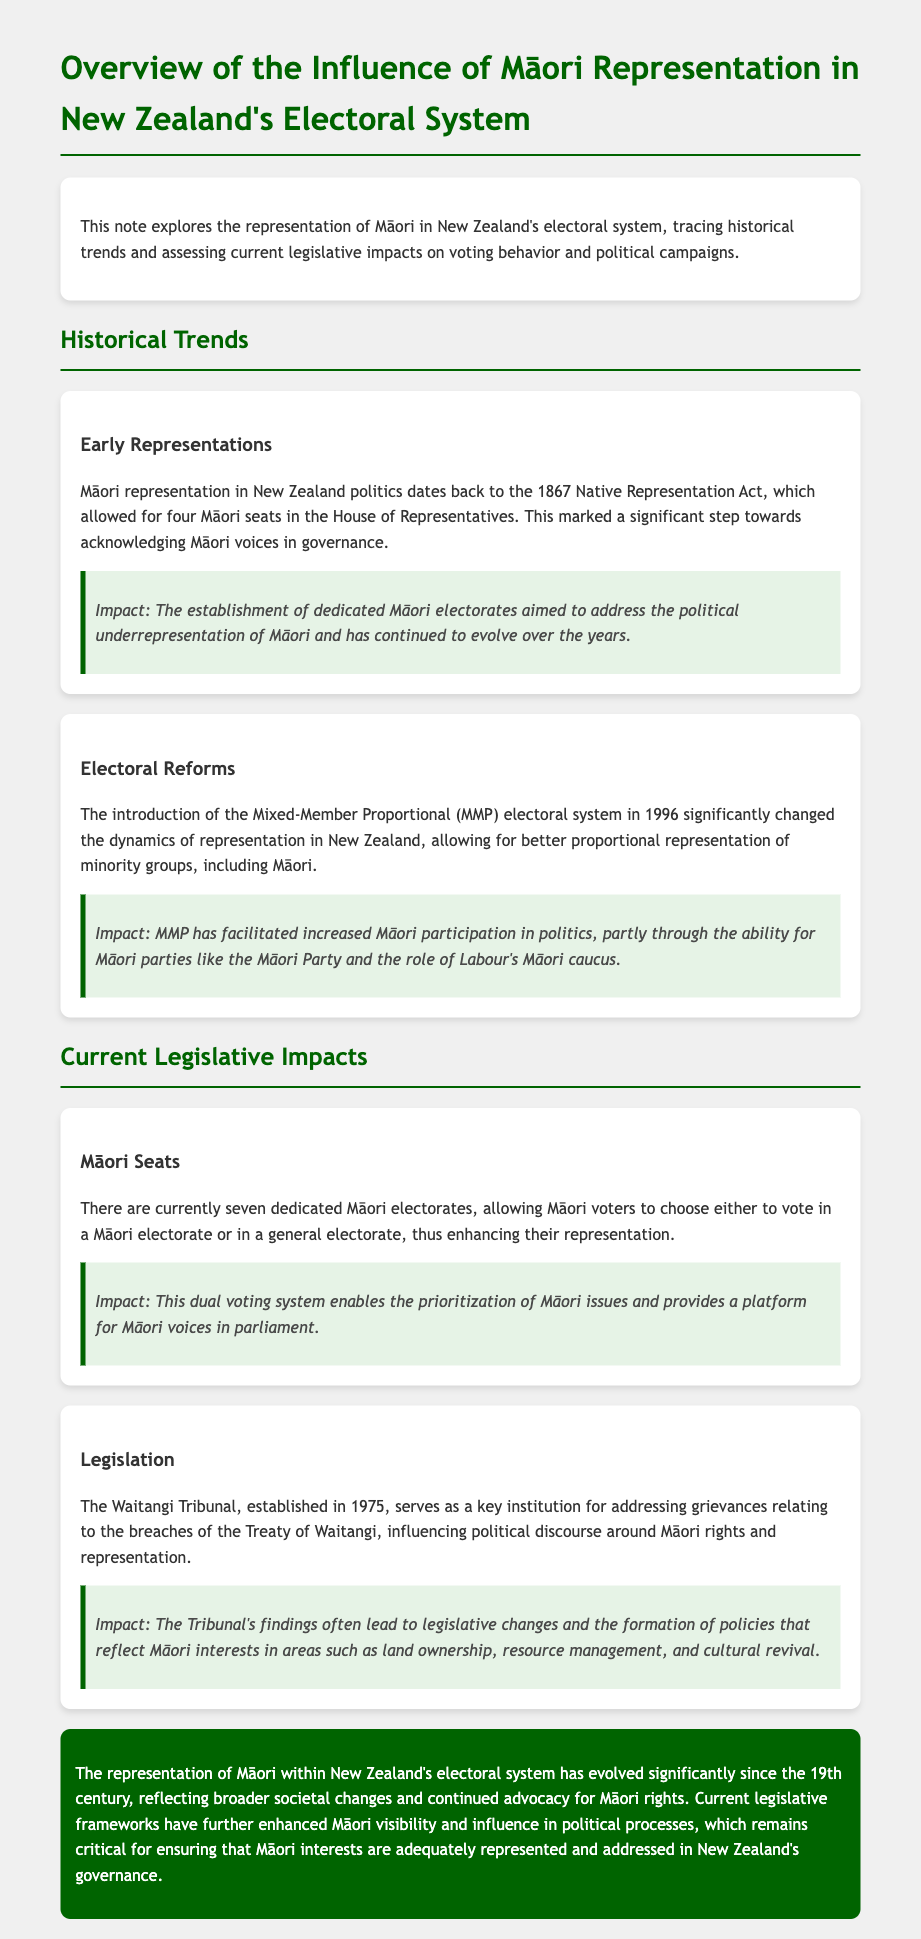what year was the Native Representation Act enacted? The Native Representation Act was enacted in 1867.
Answer: 1867 how many Māori electorates currently exist? There are currently seven dedicated Māori electorates.
Answer: seven what electoral system was introduced in 1996? The Mixed-Member Proportional (MMP) electoral system was introduced in 1996.
Answer: Mixed-Member Proportional what does the Waitangi Tribunal address? The Waitangi Tribunal addresses grievances relating to the breaches of the Treaty of Waitangi.
Answer: grievances what is one impact of the establishment of Māori seats? The establishment of Māori seats enables the prioritization of Māori issues.
Answer: prioritization of Māori issues how did MMP impact Māori participation? MMP has facilitated increased Māori participation in politics.
Answer: increased Māori participation what institution was established in 1975? The Waitangi Tribunal was established in 1975.
Answer: Waitangi Tribunal which parliamentary parties support Māori interests? Māori Party and Labour's Māori caucus support Māori interests.
Answer: Māori Party and Labour's Māori caucus 